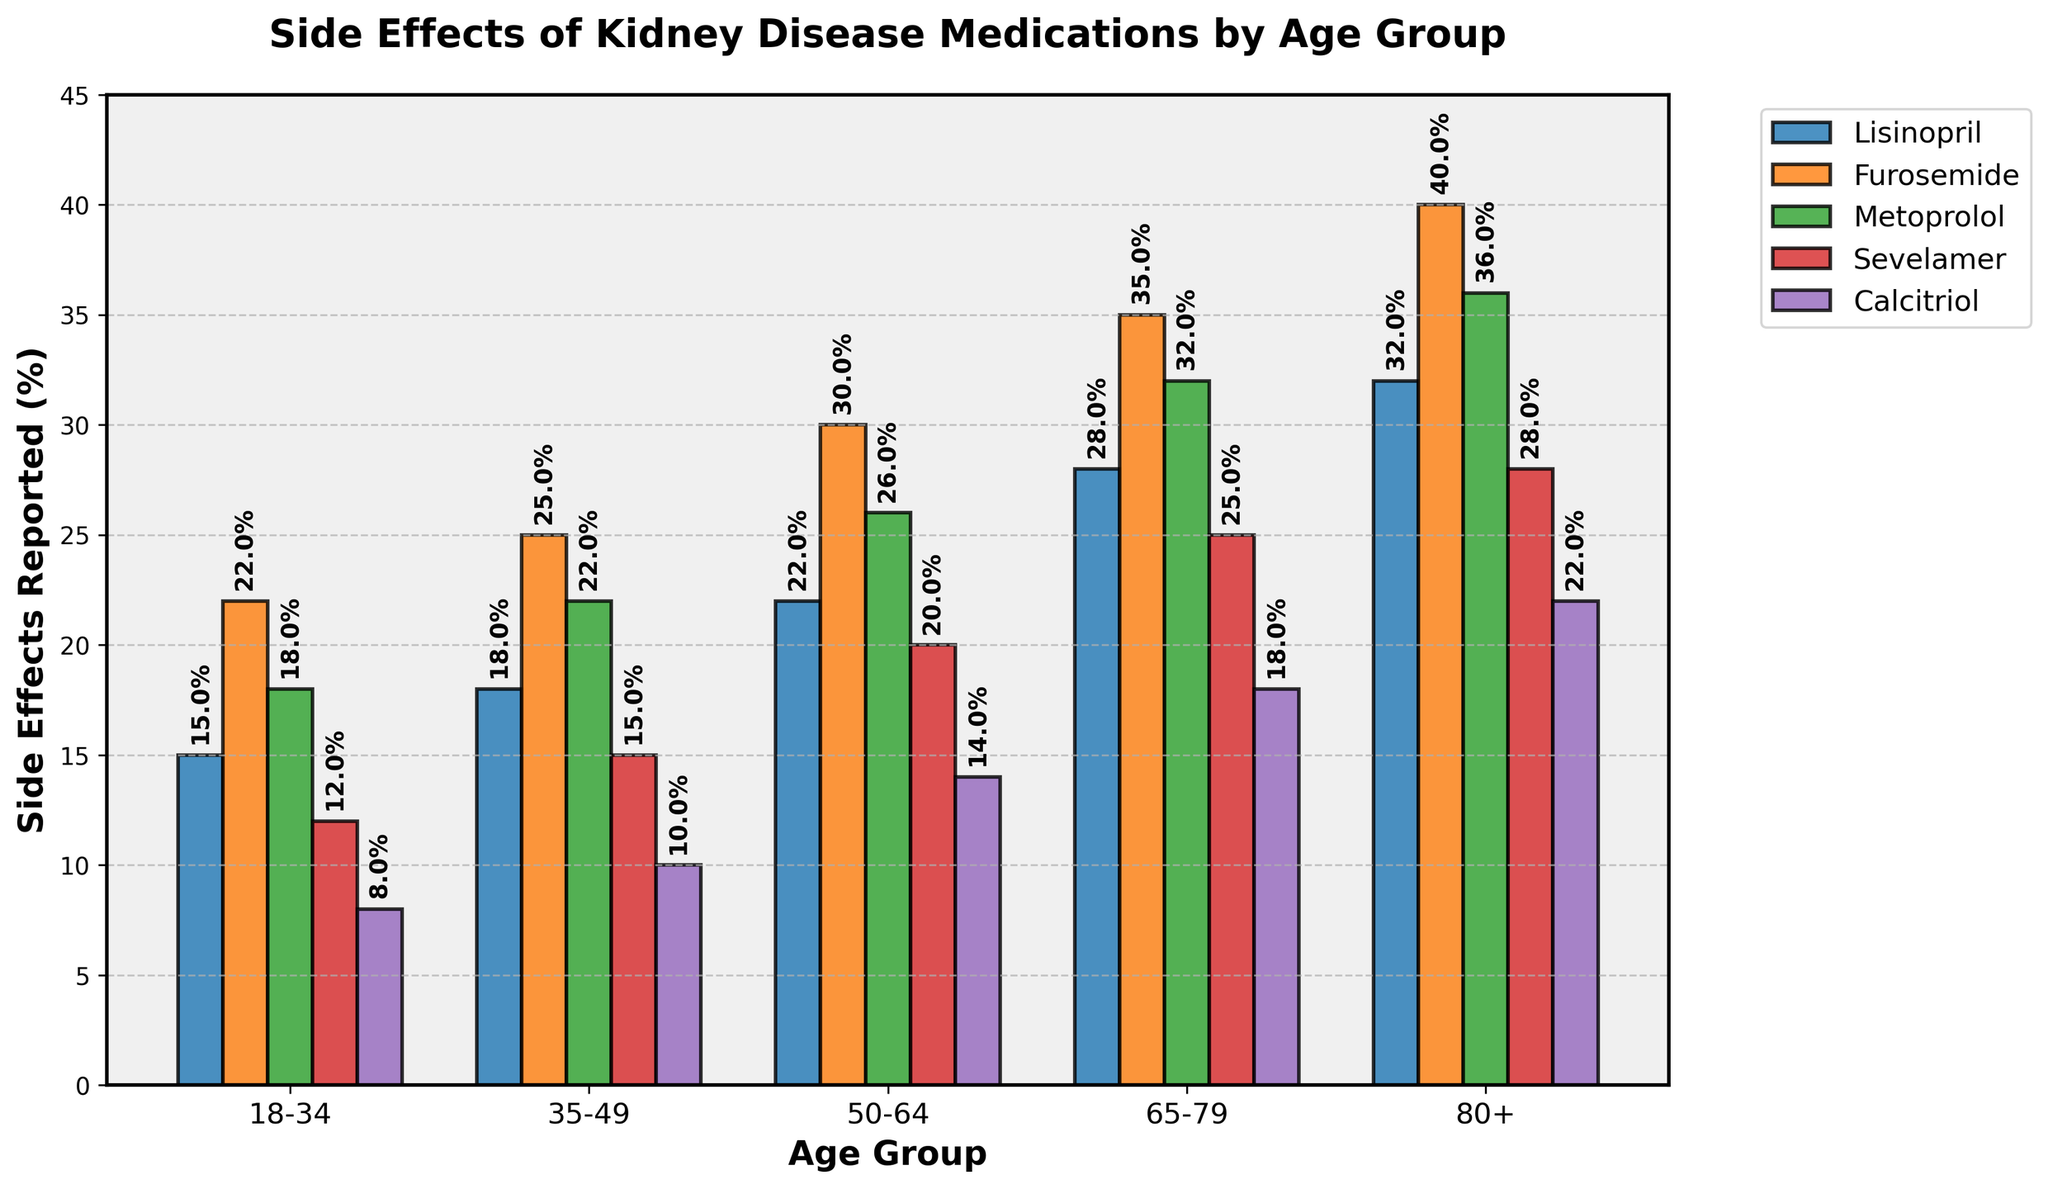Which age group reports the highest side effects for Lisinopril? To find this, look for the tallest bar in the Lisinopril section. The age group 80+ has the tallest bar at about 32%.
Answer: 80+ In the age group 50-64, which medication has the lowest reported side effects? In the 50-64 age group, compare the heights of the bars for each medication. Calcitriol shows the lowest side effect rate at 14%.
Answer: Calcitriol How do the side effects for Metoprolol compare between the youngest (18-34) and the oldest (80+) age groups? The bar for Metoprolol in the 18-34 age group reaches 18%, whereas for the 80+ group, it reaches 36%. Thus, side effects are doubled in the oldest age group.
Answer: Double What is the average percentage of reported side effects for Sevelamer across all age groups? Add the percentages of side effects for Sevelamer across all age groups and divide by the number of age groups: (12% + 15% + 20% + 25% + 28%) / 5 = 20%.
Answer: 20% Which medication generally shows an increase in side effects with age in all age groups? Check each medication's bar heights progressively increasing or staying constant from 18-34 to 80+. All the medications (Lisinopril, Furosemide, Metoprolol, Sevelamer, Calcitriol) show increasing side effects with age.
Answer: All Between Furosemide and Calcitriol, which medication has a higher percentage of side effects reported in the 65-79 age group? Compare the heights of the bars for Furosemide and Calcitriol in the 65-79 age group. Furosemide has a higher reported side effect percentage at 35% versus Calcitriol's 18%.
Answer: Furosemide What is the difference in the side effects percentage for Lisinopril between age groups 35-49 and 65-79? Subtract the percentage of side effects reported for Lisinopril in the age group 35-49 (18%) from that in the 65-79 age group (28%). 28% - 18% = 10%.
Answer: 10% Which age group's reported side effects percentage for Sevelamer is closest to 20%? Identify the age group whose bar for Sevelamer is at or nearest to 20%. This is seen in the 50-64 age group, which exactly reports 20%.
Answer: 50-64 Across all age groups, which medication has the widest gap in reported side effects percentages between the youngest and the oldest age groups? Calculate the differences in side effects percentages between the 18-34 and 80+ age groups for all medications. Furosemide has the widest gap: 40% - 22% = 18%.
Answer: Furosemide 